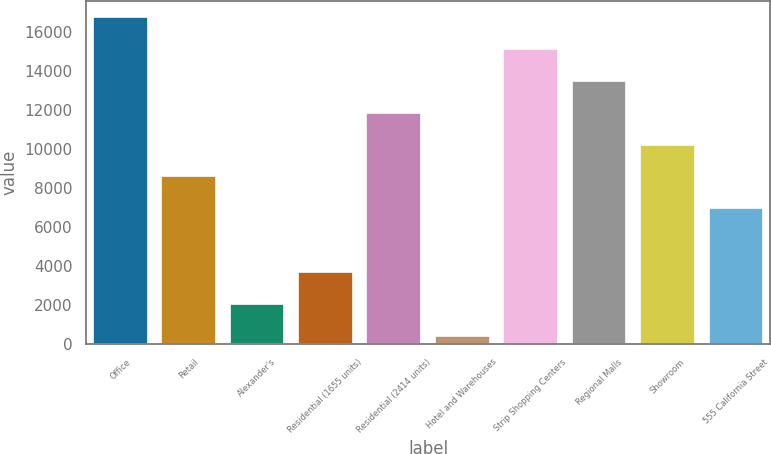Convert chart to OTSL. <chart><loc_0><loc_0><loc_500><loc_500><bar_chart><fcel>Office<fcel>Retail<fcel>Alexander's<fcel>Residential (1655 units)<fcel>Residential (2414 units)<fcel>Hotel and Warehouses<fcel>Strip Shopping Centers<fcel>Regional Malls<fcel>Showroom<fcel>555 California Street<nl><fcel>16751<fcel>8593<fcel>2066.6<fcel>3698.2<fcel>11856.2<fcel>435<fcel>15119.4<fcel>13487.8<fcel>10224.6<fcel>6961.4<nl></chart> 